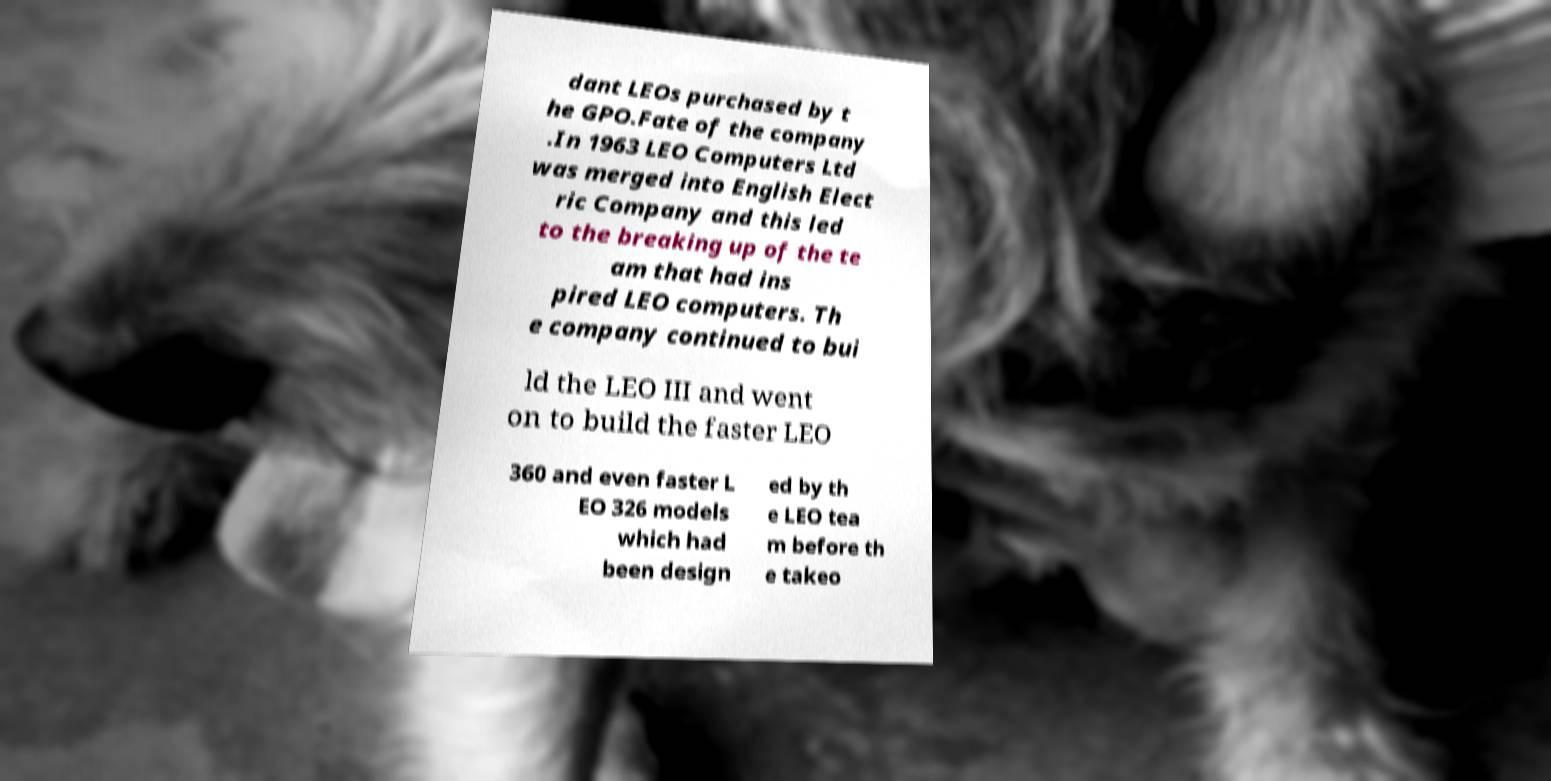Please read and relay the text visible in this image. What does it say? dant LEOs purchased by t he GPO.Fate of the company .In 1963 LEO Computers Ltd was merged into English Elect ric Company and this led to the breaking up of the te am that had ins pired LEO computers. Th e company continued to bui ld the LEO III and went on to build the faster LEO 360 and even faster L EO 326 models which had been design ed by th e LEO tea m before th e takeo 